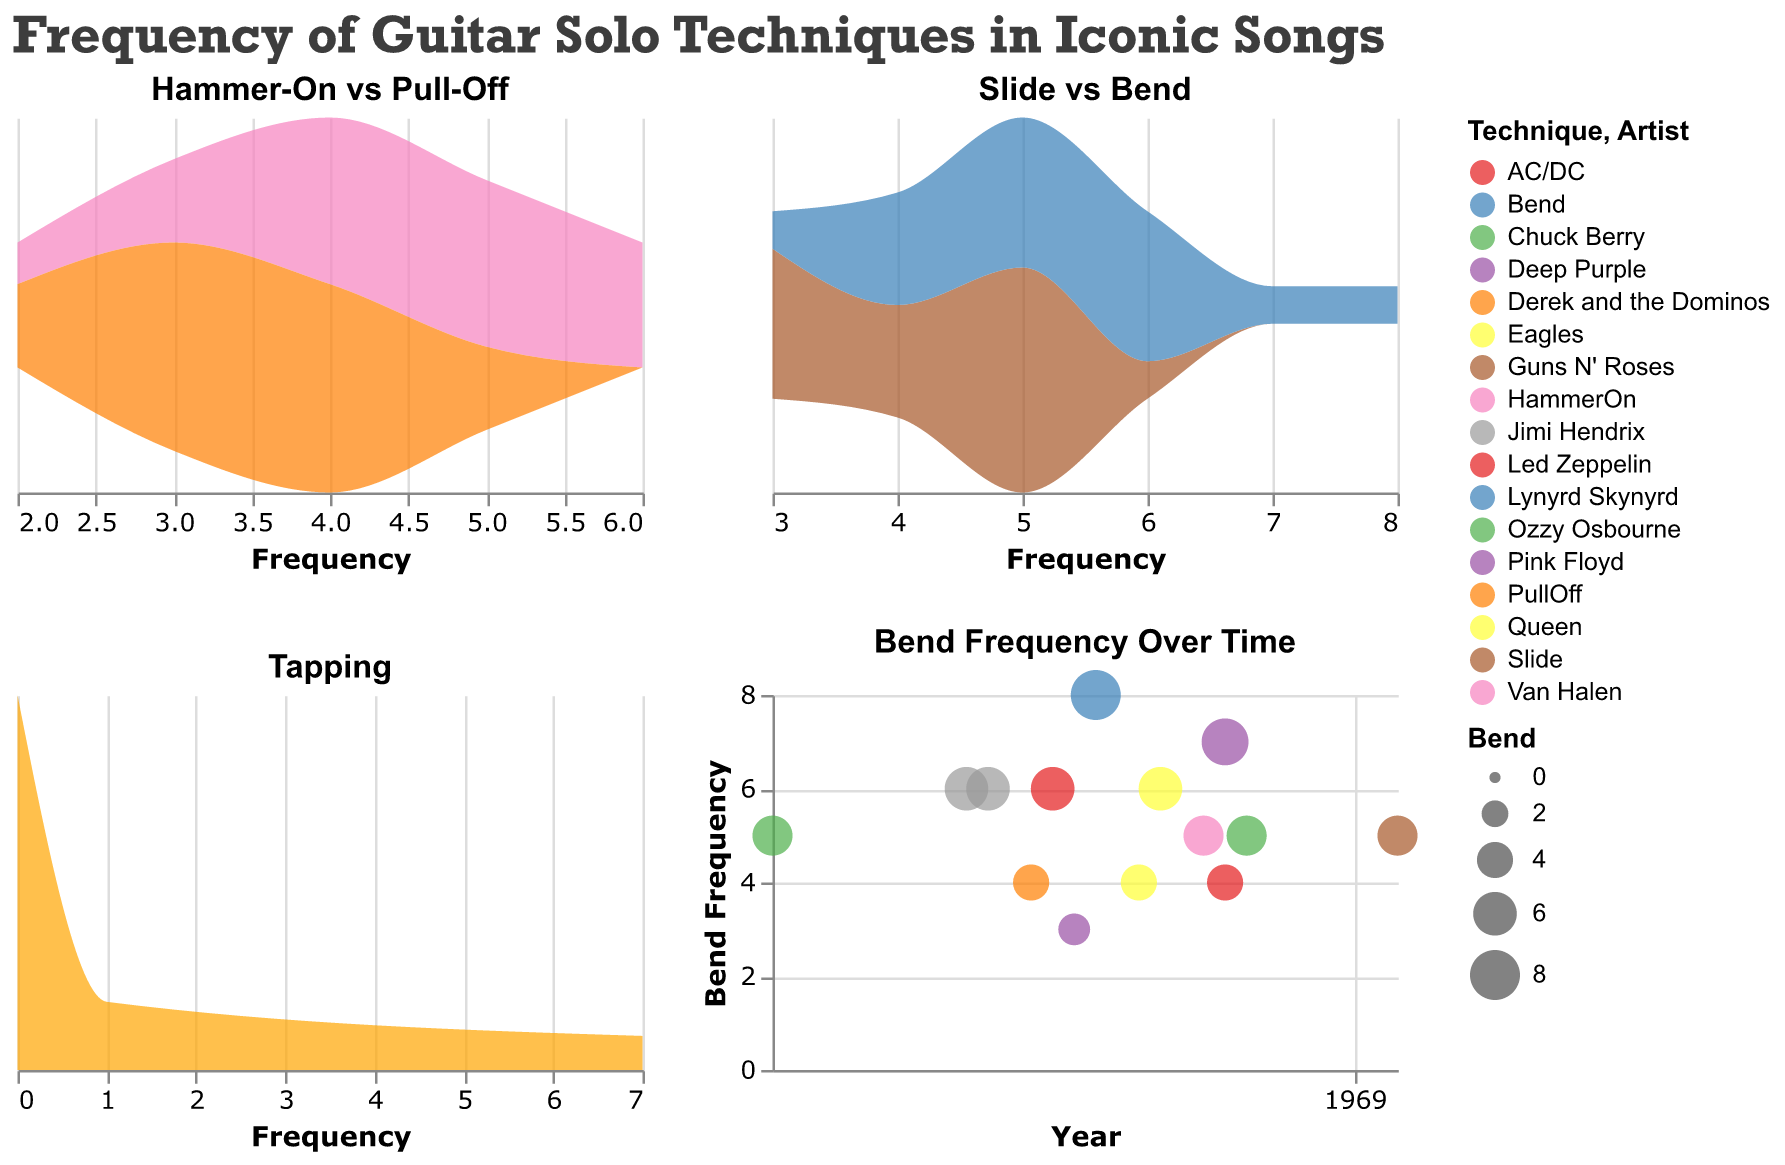What are the two techniques compared in the first plot? The first plot's title is "Hammer-On vs Pull-Off," indicating it compares two techniques: Hammer-On and Pull-Off.
Answer: Hammer-On, Pull-Off Which technique has the highest density in the "Slide vs Bend" plot? By observing the density areas in the "Slide vs Bend" plot, the color representing 'Bend' shows a higher density at peak compared to 'Slide'.
Answer: Bend How many songs feature tapping, as per the Tapping frequency plot? By examining the third subplot titled "Tapping", there are 4 peak points, each representing a song that features tapping.
Answer: 4 In which year did songs with the highest bend frequency appear? The last plot with the title "Bend Frequency Over Time" shows a bubble for Bend frequency over years. The largest bubble, representing the highest bend frequency, is in 1973.
Answer: 1973 Compare the maximum frequency of Hammer-On and Pull-Off techniques. Which one is higher? In the first subplot, observe the peak density of both Hammer-On and Pull-Off frequencies. Hammer-On peaks at 6, while Pull-Off peaks at 5. Therefore, Hammer-On has a higher maximum frequency.
Answer: Hammer-On What is the most common frequency range for Slide technique in the "Slide vs Bend" plot? The common frequency range can be estimated by observing the area under the "Slide" curve in the second subplot. Most densities lie in the 3-5 frequency range.
Answer: 3-5 Which artist's song is represented by the largest bubble in the "Bend Frequency Over Time" plot? Hover over or check the tooltip for the largest bubble in the "Bend Frequency Over Time" plot. It is associated with Lynyrd Skynyrd's "Free Bird" in 1973.
Answer: Lynyrd Skynyrd Are there any songs with a Pull-Off frequency of 2 according to the Hammer-On vs Pull-Off plot? Look at the x-axis on the first subplot for Pull-Off and check if there are density areas marked at frequency 2. There is a small peak at 2, indicating some songs use it.
Answer: Yes Which guitar solo technique is least common overall? Based on visual inspection across all plots, the Tapping plot has the least density peaks both in frequency and count of songs, indicating it is the least common technique.
Answer: Tapping What is the average frequency of the Hammer-On technique for all the songs? The first subplot (Hammer-On vs Pull-Off) shows various density peaks. Compute the average by summing up the total Hammer-On frequencies (5+6+4+2+3+5+4+4+6+6+3+4+5+5) and dividing by 14 (number of songs). Sum is 62, and the average is 62/14 = 4.43 (approx.)
Answer: 4.43 